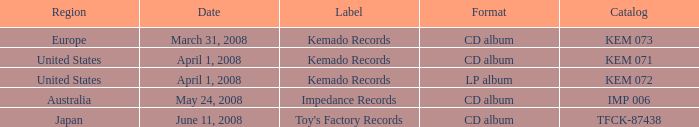Which Format has a Label of toy's factory records? CD album. 